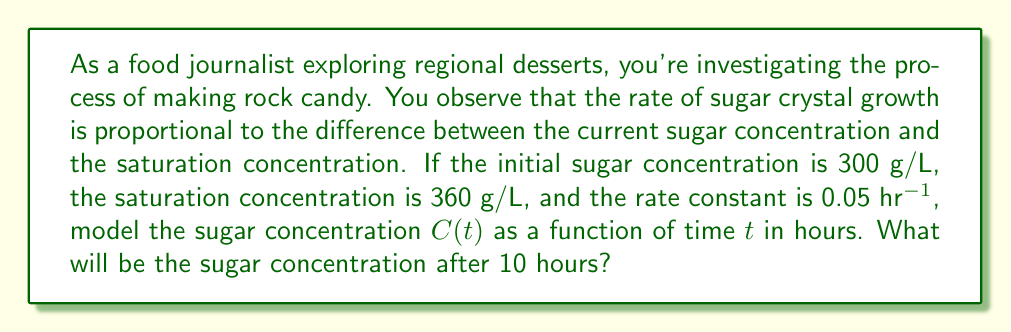Solve this math problem. To model the sugar concentration, we can use a first-order differential equation:

$$\frac{dC}{dt} = k(C_s - C)$$

Where:
- $C$ is the sugar concentration (g/L)
- $t$ is time (hours)
- $k$ is the rate constant (hr^(-1))
- $C_s$ is the saturation concentration (g/L)

Given:
- Initial concentration $C_0 = 300$ g/L
- Saturation concentration $C_s = 360$ g/L
- Rate constant $k = 0.05$ hr^(-1)

The solution to this differential equation is:

$$C(t) = C_s - (C_s - C_0)e^{-kt}$$

Substituting the given values:

$$C(t) = 360 - (360 - 300)e^{-0.05t}$$

$$C(t) = 360 - 60e^{-0.05t}$$

To find the concentration after 10 hours, we substitute $t = 10$:

$$C(10) = 360 - 60e^{-0.05(10)}$$
$$C(10) = 360 - 60e^{-0.5}$$
$$C(10) = 360 - 60(0.6065)$$
$$C(10) = 360 - 36.39$$
$$C(10) = 323.61$$

Therefore, after 10 hours, the sugar concentration will be approximately 323.61 g/L.
Answer: 323.61 g/L 